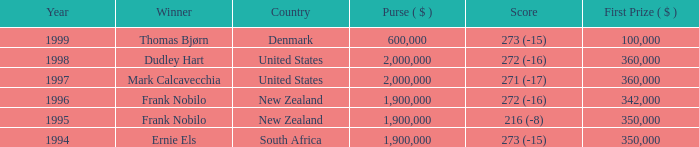What was the top first place prize in 1997? 360000.0. 